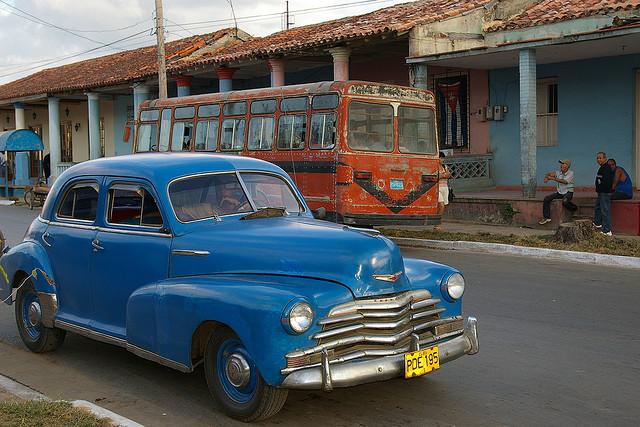What type of car is shown?
Concise answer only. Chevy. What color is the car's plate?
Concise answer only. Yellow. How many red semis in the picture?
Keep it brief. 0. Is this taken in Cuba?
Keep it brief. Yes. Is this a car one solid color?
Be succinct. Yes. 